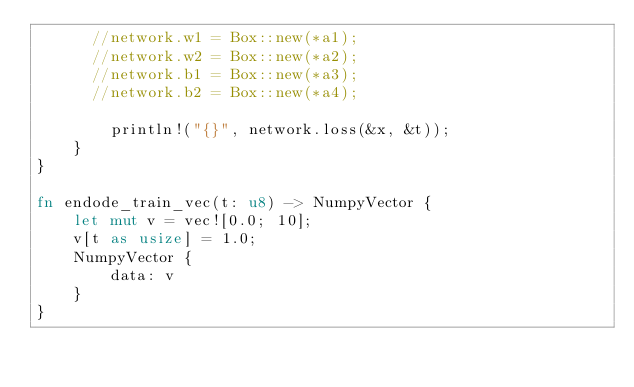<code> <loc_0><loc_0><loc_500><loc_500><_Rust_>      //network.w1 = Box::new(*a1);
      //network.w2 = Box::new(*a2);
      //network.b1 = Box::new(*a3);
      //network.b2 = Box::new(*a4);

        println!("{}", network.loss(&x, &t));
    }
}

fn endode_train_vec(t: u8) -> NumpyVector {
    let mut v = vec![0.0; 10];
    v[t as usize] = 1.0;
    NumpyVector {
        data: v
    }
}
</code> 